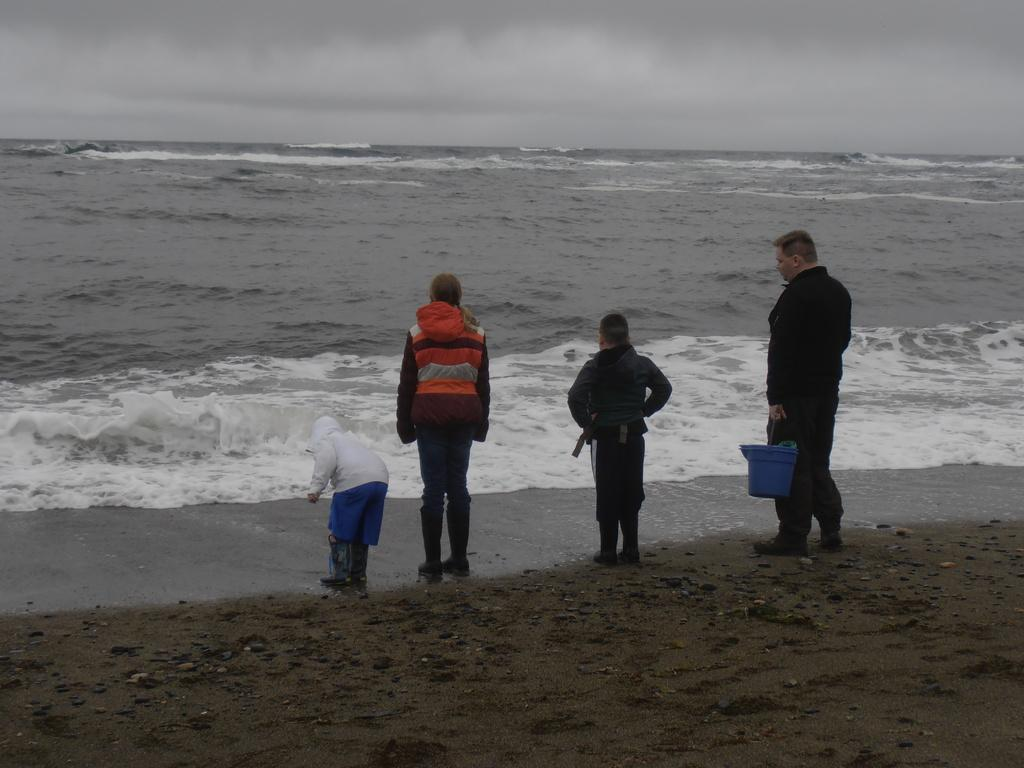How many people are in the image? There are four persons in the image. Where are the persons located in the image? The persons are standing near the seashore. What can be seen besides the people in the image? There is water visible in the image. What is visible in the background of the image? The sky is visible in the background of the image. What type of cars can be seen driving on the seashore in the image? There are no cars visible in the image; it features four persons standing near the seashore. 